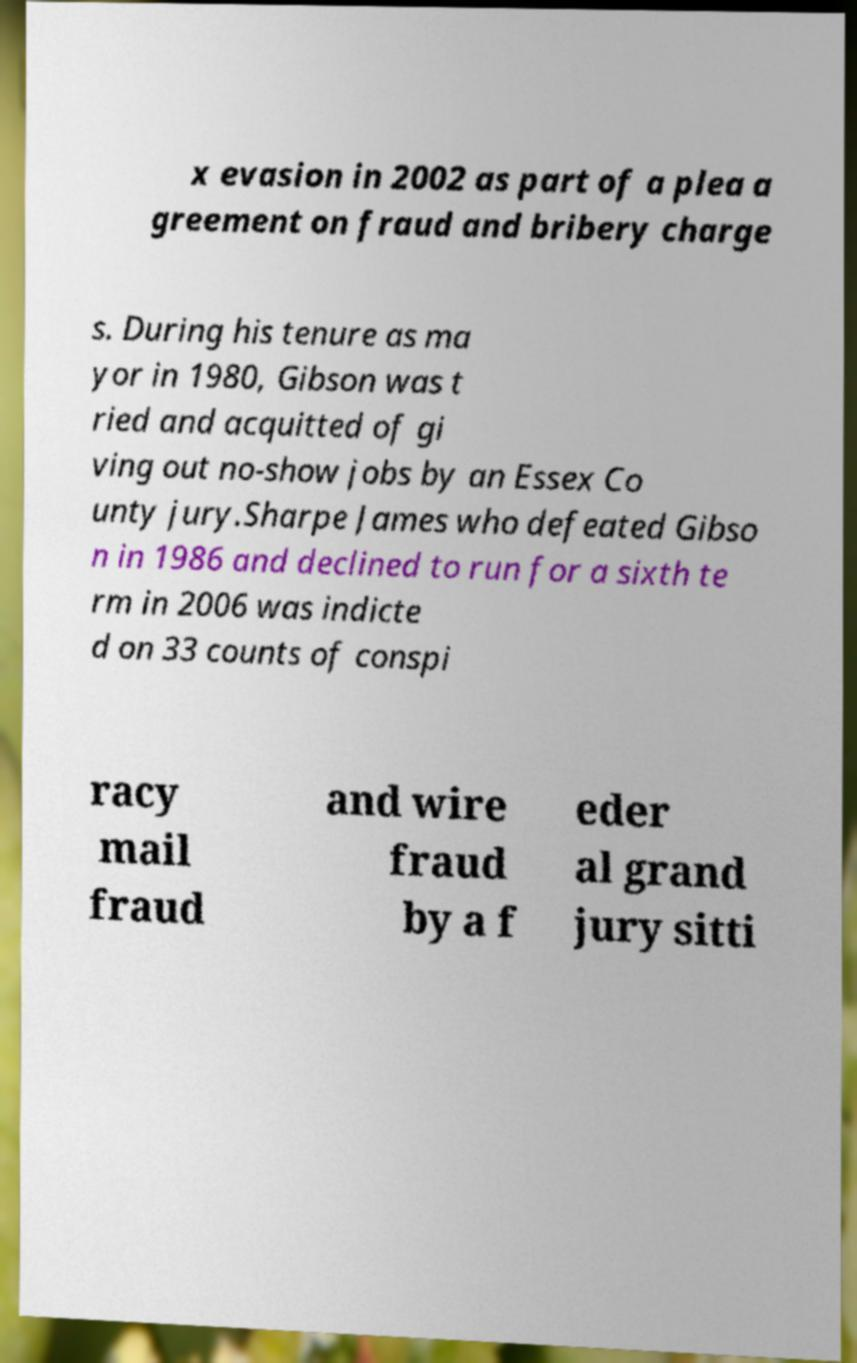Please identify and transcribe the text found in this image. x evasion in 2002 as part of a plea a greement on fraud and bribery charge s. During his tenure as ma yor in 1980, Gibson was t ried and acquitted of gi ving out no-show jobs by an Essex Co unty jury.Sharpe James who defeated Gibso n in 1986 and declined to run for a sixth te rm in 2006 was indicte d on 33 counts of conspi racy mail fraud and wire fraud by a f eder al grand jury sitti 